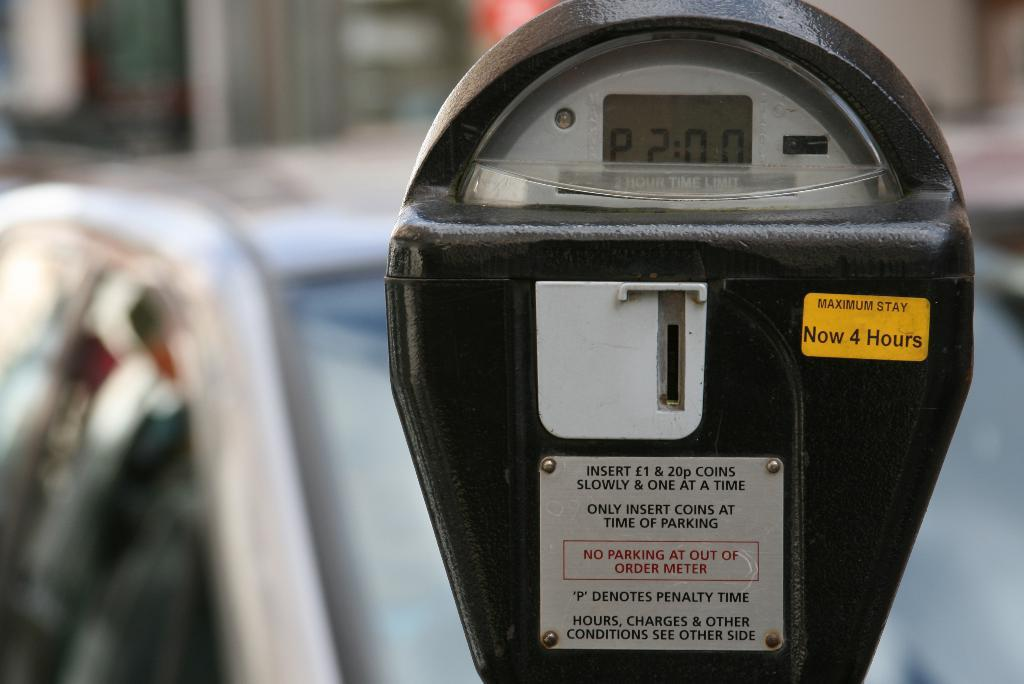<image>
Summarize the visual content of the image. A parking meter displays two hours on the timer for a maximum of 4 hours. 